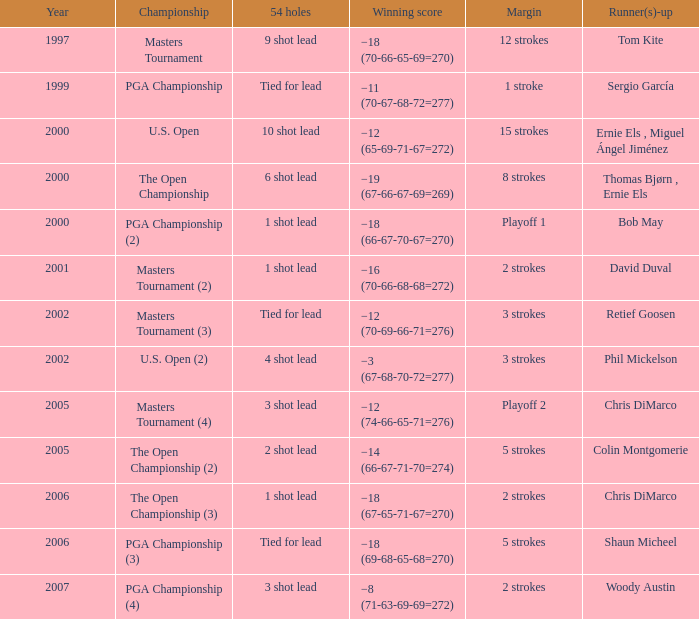 what's the championship where 54 holes is 1 shot lead and runner(s)-up is chris dimarco The Open Championship (3). 